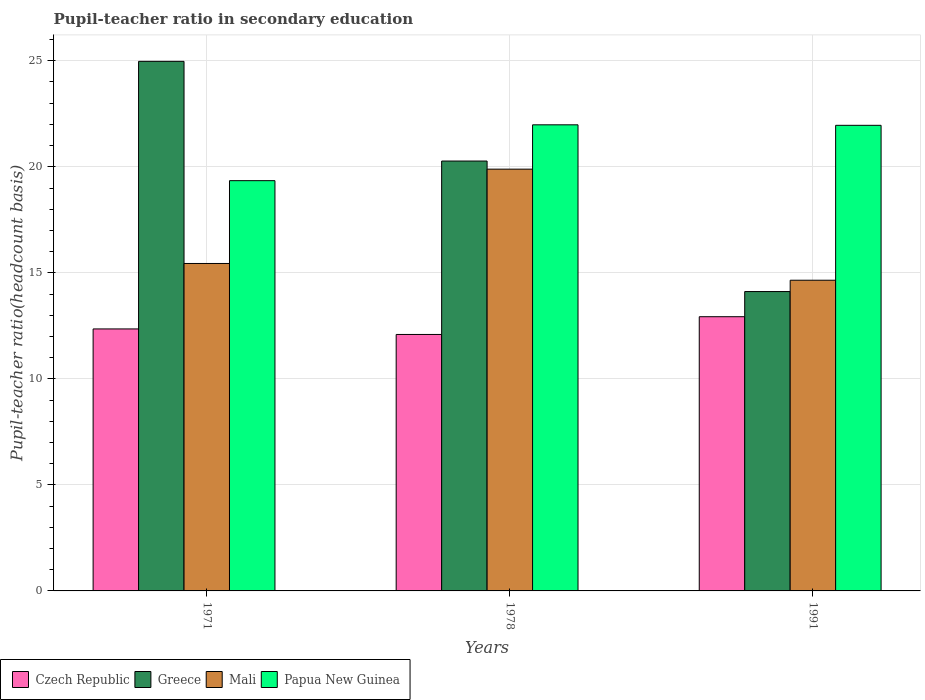Are the number of bars per tick equal to the number of legend labels?
Provide a succinct answer. Yes. How many bars are there on the 3rd tick from the right?
Keep it short and to the point. 4. What is the label of the 2nd group of bars from the left?
Provide a succinct answer. 1978. In how many cases, is the number of bars for a given year not equal to the number of legend labels?
Your response must be concise. 0. What is the pupil-teacher ratio in secondary education in Greece in 1978?
Your answer should be compact. 20.27. Across all years, what is the maximum pupil-teacher ratio in secondary education in Greece?
Your answer should be very brief. 24.97. Across all years, what is the minimum pupil-teacher ratio in secondary education in Mali?
Provide a succinct answer. 14.65. In which year was the pupil-teacher ratio in secondary education in Mali maximum?
Keep it short and to the point. 1978. In which year was the pupil-teacher ratio in secondary education in Greece minimum?
Make the answer very short. 1991. What is the total pupil-teacher ratio in secondary education in Czech Republic in the graph?
Your answer should be very brief. 37.38. What is the difference between the pupil-teacher ratio in secondary education in Mali in 1971 and that in 1991?
Offer a very short reply. 0.79. What is the difference between the pupil-teacher ratio in secondary education in Papua New Guinea in 1991 and the pupil-teacher ratio in secondary education in Greece in 1978?
Your response must be concise. 1.68. What is the average pupil-teacher ratio in secondary education in Papua New Guinea per year?
Offer a terse response. 21.09. In the year 1971, what is the difference between the pupil-teacher ratio in secondary education in Greece and pupil-teacher ratio in secondary education in Mali?
Your answer should be compact. 9.53. What is the ratio of the pupil-teacher ratio in secondary education in Greece in 1971 to that in 1991?
Your answer should be very brief. 1.77. What is the difference between the highest and the second highest pupil-teacher ratio in secondary education in Greece?
Offer a terse response. 4.7. What is the difference between the highest and the lowest pupil-teacher ratio in secondary education in Czech Republic?
Provide a succinct answer. 0.84. In how many years, is the pupil-teacher ratio in secondary education in Mali greater than the average pupil-teacher ratio in secondary education in Mali taken over all years?
Provide a short and direct response. 1. Is it the case that in every year, the sum of the pupil-teacher ratio in secondary education in Greece and pupil-teacher ratio in secondary education in Papua New Guinea is greater than the sum of pupil-teacher ratio in secondary education in Mali and pupil-teacher ratio in secondary education in Czech Republic?
Provide a short and direct response. Yes. What does the 4th bar from the left in 1991 represents?
Keep it short and to the point. Papua New Guinea. What does the 2nd bar from the right in 1971 represents?
Your answer should be very brief. Mali. How many bars are there?
Offer a terse response. 12. Are all the bars in the graph horizontal?
Make the answer very short. No. Are the values on the major ticks of Y-axis written in scientific E-notation?
Your answer should be compact. No. How are the legend labels stacked?
Your answer should be very brief. Horizontal. What is the title of the graph?
Provide a succinct answer. Pupil-teacher ratio in secondary education. Does "OECD members" appear as one of the legend labels in the graph?
Your response must be concise. No. What is the label or title of the X-axis?
Your response must be concise. Years. What is the label or title of the Y-axis?
Keep it short and to the point. Pupil-teacher ratio(headcount basis). What is the Pupil-teacher ratio(headcount basis) in Czech Republic in 1971?
Offer a terse response. 12.36. What is the Pupil-teacher ratio(headcount basis) in Greece in 1971?
Keep it short and to the point. 24.97. What is the Pupil-teacher ratio(headcount basis) of Mali in 1971?
Provide a short and direct response. 15.44. What is the Pupil-teacher ratio(headcount basis) of Papua New Guinea in 1971?
Make the answer very short. 19.35. What is the Pupil-teacher ratio(headcount basis) in Czech Republic in 1978?
Ensure brevity in your answer.  12.09. What is the Pupil-teacher ratio(headcount basis) in Greece in 1978?
Offer a very short reply. 20.27. What is the Pupil-teacher ratio(headcount basis) in Mali in 1978?
Your answer should be very brief. 19.89. What is the Pupil-teacher ratio(headcount basis) in Papua New Guinea in 1978?
Your answer should be compact. 21.98. What is the Pupil-teacher ratio(headcount basis) in Czech Republic in 1991?
Your response must be concise. 12.93. What is the Pupil-teacher ratio(headcount basis) of Greece in 1991?
Make the answer very short. 14.12. What is the Pupil-teacher ratio(headcount basis) in Mali in 1991?
Offer a terse response. 14.65. What is the Pupil-teacher ratio(headcount basis) of Papua New Guinea in 1991?
Make the answer very short. 21.96. Across all years, what is the maximum Pupil-teacher ratio(headcount basis) of Czech Republic?
Give a very brief answer. 12.93. Across all years, what is the maximum Pupil-teacher ratio(headcount basis) of Greece?
Offer a very short reply. 24.97. Across all years, what is the maximum Pupil-teacher ratio(headcount basis) of Mali?
Make the answer very short. 19.89. Across all years, what is the maximum Pupil-teacher ratio(headcount basis) in Papua New Guinea?
Give a very brief answer. 21.98. Across all years, what is the minimum Pupil-teacher ratio(headcount basis) in Czech Republic?
Ensure brevity in your answer.  12.09. Across all years, what is the minimum Pupil-teacher ratio(headcount basis) in Greece?
Keep it short and to the point. 14.12. Across all years, what is the minimum Pupil-teacher ratio(headcount basis) of Mali?
Offer a terse response. 14.65. Across all years, what is the minimum Pupil-teacher ratio(headcount basis) in Papua New Guinea?
Offer a very short reply. 19.35. What is the total Pupil-teacher ratio(headcount basis) of Czech Republic in the graph?
Offer a very short reply. 37.38. What is the total Pupil-teacher ratio(headcount basis) in Greece in the graph?
Keep it short and to the point. 59.36. What is the total Pupil-teacher ratio(headcount basis) in Mali in the graph?
Your answer should be very brief. 49.98. What is the total Pupil-teacher ratio(headcount basis) of Papua New Guinea in the graph?
Your answer should be very brief. 63.28. What is the difference between the Pupil-teacher ratio(headcount basis) of Czech Republic in 1971 and that in 1978?
Offer a very short reply. 0.26. What is the difference between the Pupil-teacher ratio(headcount basis) of Greece in 1971 and that in 1978?
Your answer should be compact. 4.7. What is the difference between the Pupil-teacher ratio(headcount basis) in Mali in 1971 and that in 1978?
Provide a succinct answer. -4.45. What is the difference between the Pupil-teacher ratio(headcount basis) in Papua New Guinea in 1971 and that in 1978?
Provide a succinct answer. -2.63. What is the difference between the Pupil-teacher ratio(headcount basis) of Czech Republic in 1971 and that in 1991?
Your answer should be very brief. -0.58. What is the difference between the Pupil-teacher ratio(headcount basis) of Greece in 1971 and that in 1991?
Your answer should be compact. 10.86. What is the difference between the Pupil-teacher ratio(headcount basis) of Mali in 1971 and that in 1991?
Offer a terse response. 0.79. What is the difference between the Pupil-teacher ratio(headcount basis) of Papua New Guinea in 1971 and that in 1991?
Give a very brief answer. -2.61. What is the difference between the Pupil-teacher ratio(headcount basis) in Czech Republic in 1978 and that in 1991?
Your answer should be compact. -0.84. What is the difference between the Pupil-teacher ratio(headcount basis) of Greece in 1978 and that in 1991?
Make the answer very short. 6.15. What is the difference between the Pupil-teacher ratio(headcount basis) in Mali in 1978 and that in 1991?
Provide a succinct answer. 5.24. What is the difference between the Pupil-teacher ratio(headcount basis) of Papua New Guinea in 1978 and that in 1991?
Offer a very short reply. 0.02. What is the difference between the Pupil-teacher ratio(headcount basis) of Czech Republic in 1971 and the Pupil-teacher ratio(headcount basis) of Greece in 1978?
Keep it short and to the point. -7.92. What is the difference between the Pupil-teacher ratio(headcount basis) in Czech Republic in 1971 and the Pupil-teacher ratio(headcount basis) in Mali in 1978?
Keep it short and to the point. -7.54. What is the difference between the Pupil-teacher ratio(headcount basis) in Czech Republic in 1971 and the Pupil-teacher ratio(headcount basis) in Papua New Guinea in 1978?
Keep it short and to the point. -9.63. What is the difference between the Pupil-teacher ratio(headcount basis) in Greece in 1971 and the Pupil-teacher ratio(headcount basis) in Mali in 1978?
Your response must be concise. 5.08. What is the difference between the Pupil-teacher ratio(headcount basis) in Greece in 1971 and the Pupil-teacher ratio(headcount basis) in Papua New Guinea in 1978?
Give a very brief answer. 2.99. What is the difference between the Pupil-teacher ratio(headcount basis) in Mali in 1971 and the Pupil-teacher ratio(headcount basis) in Papua New Guinea in 1978?
Keep it short and to the point. -6.54. What is the difference between the Pupil-teacher ratio(headcount basis) in Czech Republic in 1971 and the Pupil-teacher ratio(headcount basis) in Greece in 1991?
Provide a short and direct response. -1.76. What is the difference between the Pupil-teacher ratio(headcount basis) in Czech Republic in 1971 and the Pupil-teacher ratio(headcount basis) in Mali in 1991?
Offer a very short reply. -2.3. What is the difference between the Pupil-teacher ratio(headcount basis) of Czech Republic in 1971 and the Pupil-teacher ratio(headcount basis) of Papua New Guinea in 1991?
Keep it short and to the point. -9.6. What is the difference between the Pupil-teacher ratio(headcount basis) in Greece in 1971 and the Pupil-teacher ratio(headcount basis) in Mali in 1991?
Give a very brief answer. 10.32. What is the difference between the Pupil-teacher ratio(headcount basis) of Greece in 1971 and the Pupil-teacher ratio(headcount basis) of Papua New Guinea in 1991?
Your response must be concise. 3.02. What is the difference between the Pupil-teacher ratio(headcount basis) in Mali in 1971 and the Pupil-teacher ratio(headcount basis) in Papua New Guinea in 1991?
Your answer should be very brief. -6.52. What is the difference between the Pupil-teacher ratio(headcount basis) of Czech Republic in 1978 and the Pupil-teacher ratio(headcount basis) of Greece in 1991?
Keep it short and to the point. -2.02. What is the difference between the Pupil-teacher ratio(headcount basis) of Czech Republic in 1978 and the Pupil-teacher ratio(headcount basis) of Mali in 1991?
Give a very brief answer. -2.56. What is the difference between the Pupil-teacher ratio(headcount basis) of Czech Republic in 1978 and the Pupil-teacher ratio(headcount basis) of Papua New Guinea in 1991?
Your answer should be very brief. -9.86. What is the difference between the Pupil-teacher ratio(headcount basis) in Greece in 1978 and the Pupil-teacher ratio(headcount basis) in Mali in 1991?
Offer a terse response. 5.62. What is the difference between the Pupil-teacher ratio(headcount basis) in Greece in 1978 and the Pupil-teacher ratio(headcount basis) in Papua New Guinea in 1991?
Offer a terse response. -1.68. What is the difference between the Pupil-teacher ratio(headcount basis) of Mali in 1978 and the Pupil-teacher ratio(headcount basis) of Papua New Guinea in 1991?
Offer a very short reply. -2.07. What is the average Pupil-teacher ratio(headcount basis) in Czech Republic per year?
Your answer should be compact. 12.46. What is the average Pupil-teacher ratio(headcount basis) of Greece per year?
Keep it short and to the point. 19.79. What is the average Pupil-teacher ratio(headcount basis) of Mali per year?
Offer a terse response. 16.66. What is the average Pupil-teacher ratio(headcount basis) of Papua New Guinea per year?
Your answer should be compact. 21.09. In the year 1971, what is the difference between the Pupil-teacher ratio(headcount basis) of Czech Republic and Pupil-teacher ratio(headcount basis) of Greece?
Offer a very short reply. -12.62. In the year 1971, what is the difference between the Pupil-teacher ratio(headcount basis) in Czech Republic and Pupil-teacher ratio(headcount basis) in Mali?
Provide a succinct answer. -3.09. In the year 1971, what is the difference between the Pupil-teacher ratio(headcount basis) of Czech Republic and Pupil-teacher ratio(headcount basis) of Papua New Guinea?
Provide a short and direct response. -6.99. In the year 1971, what is the difference between the Pupil-teacher ratio(headcount basis) of Greece and Pupil-teacher ratio(headcount basis) of Mali?
Keep it short and to the point. 9.53. In the year 1971, what is the difference between the Pupil-teacher ratio(headcount basis) of Greece and Pupil-teacher ratio(headcount basis) of Papua New Guinea?
Offer a terse response. 5.63. In the year 1971, what is the difference between the Pupil-teacher ratio(headcount basis) of Mali and Pupil-teacher ratio(headcount basis) of Papua New Guinea?
Offer a very short reply. -3.91. In the year 1978, what is the difference between the Pupil-teacher ratio(headcount basis) of Czech Republic and Pupil-teacher ratio(headcount basis) of Greece?
Provide a succinct answer. -8.18. In the year 1978, what is the difference between the Pupil-teacher ratio(headcount basis) of Czech Republic and Pupil-teacher ratio(headcount basis) of Mali?
Offer a terse response. -7.8. In the year 1978, what is the difference between the Pupil-teacher ratio(headcount basis) of Czech Republic and Pupil-teacher ratio(headcount basis) of Papua New Guinea?
Provide a short and direct response. -9.89. In the year 1978, what is the difference between the Pupil-teacher ratio(headcount basis) in Greece and Pupil-teacher ratio(headcount basis) in Mali?
Your answer should be compact. 0.38. In the year 1978, what is the difference between the Pupil-teacher ratio(headcount basis) of Greece and Pupil-teacher ratio(headcount basis) of Papua New Guinea?
Your response must be concise. -1.71. In the year 1978, what is the difference between the Pupil-teacher ratio(headcount basis) of Mali and Pupil-teacher ratio(headcount basis) of Papua New Guinea?
Your response must be concise. -2.09. In the year 1991, what is the difference between the Pupil-teacher ratio(headcount basis) of Czech Republic and Pupil-teacher ratio(headcount basis) of Greece?
Give a very brief answer. -1.19. In the year 1991, what is the difference between the Pupil-teacher ratio(headcount basis) of Czech Republic and Pupil-teacher ratio(headcount basis) of Mali?
Offer a very short reply. -1.72. In the year 1991, what is the difference between the Pupil-teacher ratio(headcount basis) in Czech Republic and Pupil-teacher ratio(headcount basis) in Papua New Guinea?
Provide a succinct answer. -9.03. In the year 1991, what is the difference between the Pupil-teacher ratio(headcount basis) of Greece and Pupil-teacher ratio(headcount basis) of Mali?
Make the answer very short. -0.53. In the year 1991, what is the difference between the Pupil-teacher ratio(headcount basis) in Greece and Pupil-teacher ratio(headcount basis) in Papua New Guinea?
Provide a short and direct response. -7.84. In the year 1991, what is the difference between the Pupil-teacher ratio(headcount basis) in Mali and Pupil-teacher ratio(headcount basis) in Papua New Guinea?
Offer a terse response. -7.3. What is the ratio of the Pupil-teacher ratio(headcount basis) in Czech Republic in 1971 to that in 1978?
Ensure brevity in your answer.  1.02. What is the ratio of the Pupil-teacher ratio(headcount basis) of Greece in 1971 to that in 1978?
Give a very brief answer. 1.23. What is the ratio of the Pupil-teacher ratio(headcount basis) in Mali in 1971 to that in 1978?
Ensure brevity in your answer.  0.78. What is the ratio of the Pupil-teacher ratio(headcount basis) in Papua New Guinea in 1971 to that in 1978?
Provide a succinct answer. 0.88. What is the ratio of the Pupil-teacher ratio(headcount basis) in Czech Republic in 1971 to that in 1991?
Make the answer very short. 0.96. What is the ratio of the Pupil-teacher ratio(headcount basis) of Greece in 1971 to that in 1991?
Your answer should be compact. 1.77. What is the ratio of the Pupil-teacher ratio(headcount basis) of Mali in 1971 to that in 1991?
Provide a succinct answer. 1.05. What is the ratio of the Pupil-teacher ratio(headcount basis) of Papua New Guinea in 1971 to that in 1991?
Make the answer very short. 0.88. What is the ratio of the Pupil-teacher ratio(headcount basis) of Czech Republic in 1978 to that in 1991?
Provide a succinct answer. 0.94. What is the ratio of the Pupil-teacher ratio(headcount basis) in Greece in 1978 to that in 1991?
Give a very brief answer. 1.44. What is the ratio of the Pupil-teacher ratio(headcount basis) of Mali in 1978 to that in 1991?
Your response must be concise. 1.36. What is the difference between the highest and the second highest Pupil-teacher ratio(headcount basis) of Czech Republic?
Give a very brief answer. 0.58. What is the difference between the highest and the second highest Pupil-teacher ratio(headcount basis) of Greece?
Your answer should be compact. 4.7. What is the difference between the highest and the second highest Pupil-teacher ratio(headcount basis) of Mali?
Provide a short and direct response. 4.45. What is the difference between the highest and the second highest Pupil-teacher ratio(headcount basis) in Papua New Guinea?
Offer a very short reply. 0.02. What is the difference between the highest and the lowest Pupil-teacher ratio(headcount basis) in Czech Republic?
Provide a short and direct response. 0.84. What is the difference between the highest and the lowest Pupil-teacher ratio(headcount basis) of Greece?
Provide a succinct answer. 10.86. What is the difference between the highest and the lowest Pupil-teacher ratio(headcount basis) in Mali?
Keep it short and to the point. 5.24. What is the difference between the highest and the lowest Pupil-teacher ratio(headcount basis) of Papua New Guinea?
Ensure brevity in your answer.  2.63. 